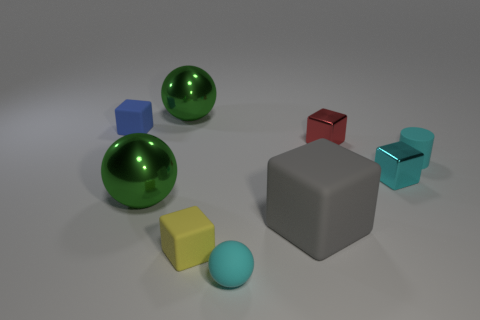What is the shape of the matte object that is behind the large rubber cube and on the left side of the red metallic thing?
Your response must be concise. Cube. How many matte things are large gray objects or tiny cylinders?
Your response must be concise. 2. There is a big object that is behind the small rubber object that is to the right of the tiny cyan rubber object that is to the left of the large gray matte thing; what is its color?
Ensure brevity in your answer.  Green. How many other things are the same material as the gray block?
Make the answer very short. 4. There is a tiny thing in front of the yellow cube; does it have the same shape as the blue thing?
Offer a terse response. No. What number of big objects are cyan balls or metallic things?
Provide a succinct answer. 2. Is the number of blue things that are behind the big block the same as the number of rubber cylinders behind the small blue rubber cube?
Provide a short and direct response. No. What number of other objects are there of the same color as the tiny matte sphere?
Your response must be concise. 2. There is a tiny sphere; does it have the same color as the small rubber thing that is right of the big gray cube?
Give a very brief answer. Yes. How many cyan objects are cylinders or large rubber objects?
Offer a very short reply. 1. 